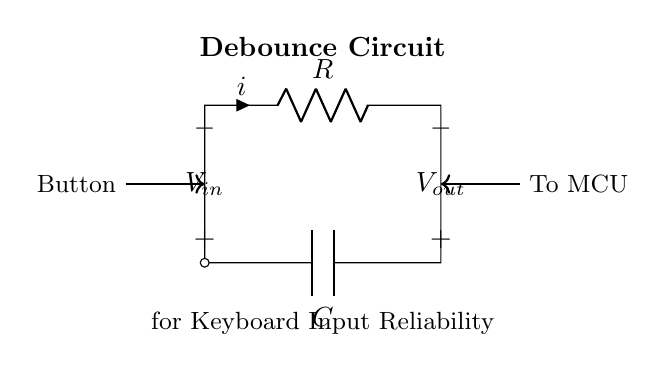What is the value of the resistor in the circuit? The resistor's value is marked as R on the schematic, but the specific numerical value is not provided in the diagram.
Answer: R What is the purpose of the capacitor in this circuit? The capacitor is used to filter out any noise in the button signal, thus providing a stable output for the keyboard input reliability.
Answer: Filtering noise What is the output voltage when the button is pressed? When the button is pressed, the voltage at Vout would typically equal Vin less any voltage drop, but the exact value is not provided in the diagram.
Answer: Undefined How does the RC time constant affect debounce time? The RC time constant, calculated by the product of resistance and capacitance (R*C), determines how quickly the output will respond to the button being pressed or released, affecting the debounce duration.
Answer: R*C In what state should the circuit ideally be to avoid false triggering? The circuit should ideally be in a stable state, which can be ensured by allowing the capacitor to charge or discharge fully before the next input signal is detected.
Answer: Stable state What happens when the button is released? When the button is released, the capacitor discharges through the resistor, which influences the output voltage levels over time depending on R and C values.
Answer: Discharge 